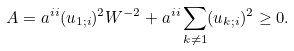<formula> <loc_0><loc_0><loc_500><loc_500>A = a ^ { i i } ( u _ { 1 ; i } ) ^ { 2 } W ^ { - 2 } + a ^ { i i } \sum _ { k \ne 1 } ( u _ { k ; i } ) ^ { 2 } \geq 0 .</formula> 